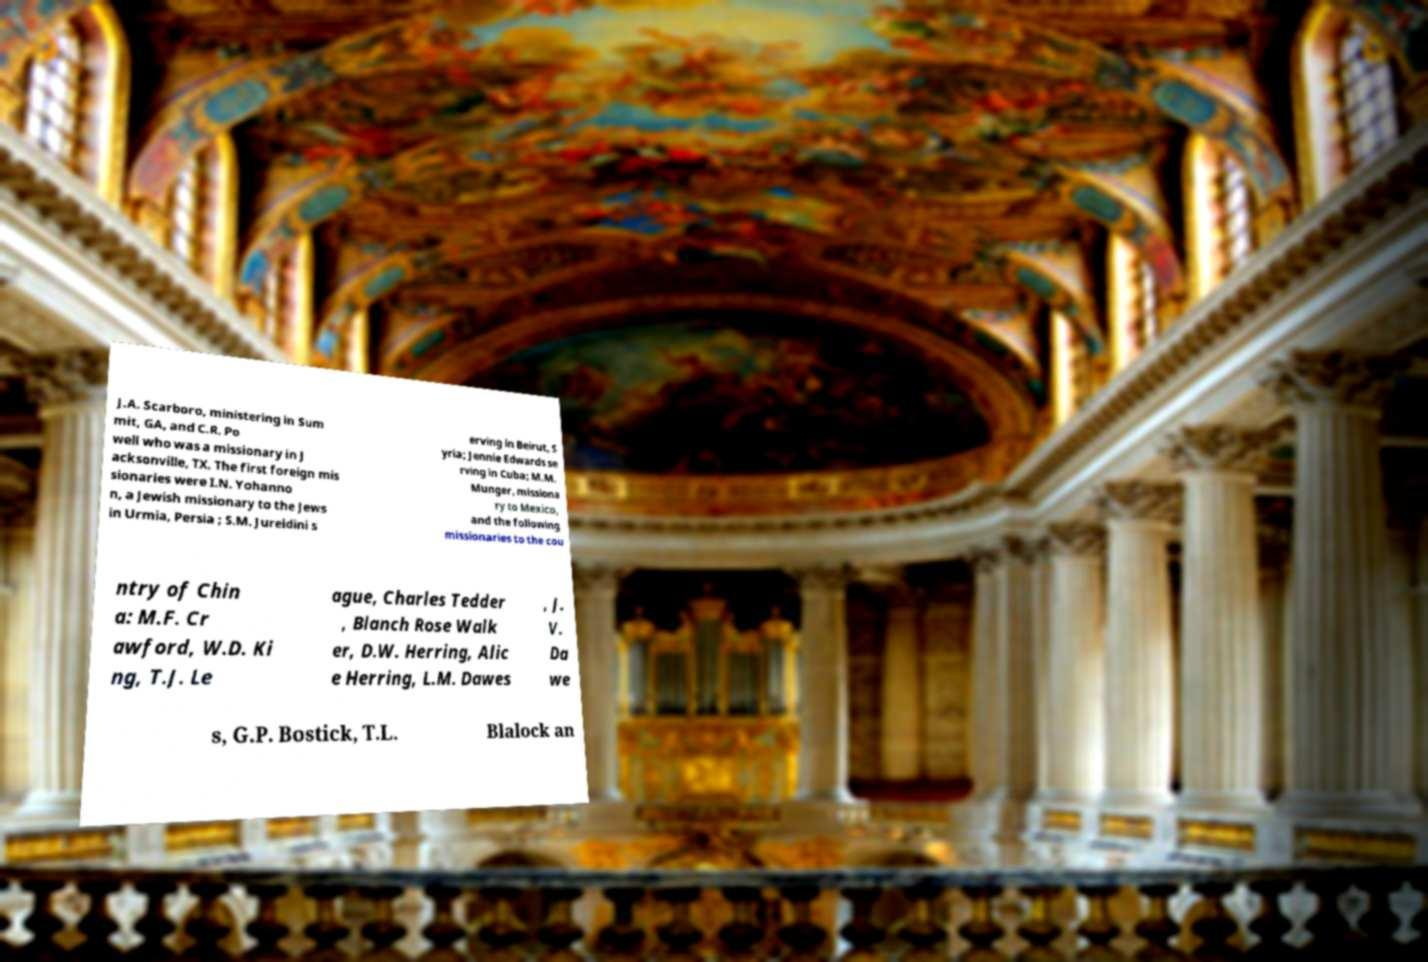I need the written content from this picture converted into text. Can you do that? J.A. Scarboro, ministering in Sum mit, GA, and C.R. Po well who was a missionary in J acksonville, TX. The first foreign mis sionaries were I.N. Yohanno n, a Jewish missionary to the Jews in Urmia, Persia ; S.M. Jureidini s erving in Beirut, S yria; Jennie Edwards se rving in Cuba; M.M. Munger, missiona ry to Mexico, and the following missionaries to the cou ntry of Chin a: M.F. Cr awford, W.D. Ki ng, T.J. Le ague, Charles Tedder , Blanch Rose Walk er, D.W. Herring, Alic e Herring, L.M. Dawes , J. V. Da we s, G.P. Bostick, T.L. Blalock an 